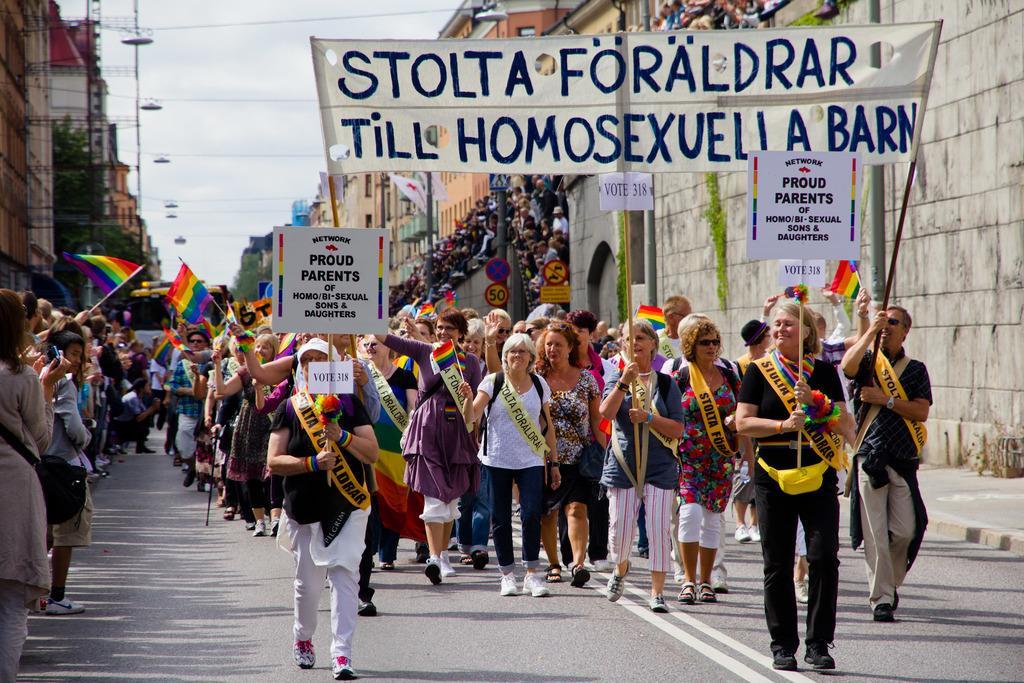How would you summarize this image in a sentence or two? In this picture I can observe some people walking on the road. Some of them are holding boards in their hands. There is some text on these boards. Most of them are women. I can observe buildings and trees on either sides of the road. In the background there is a sky. 